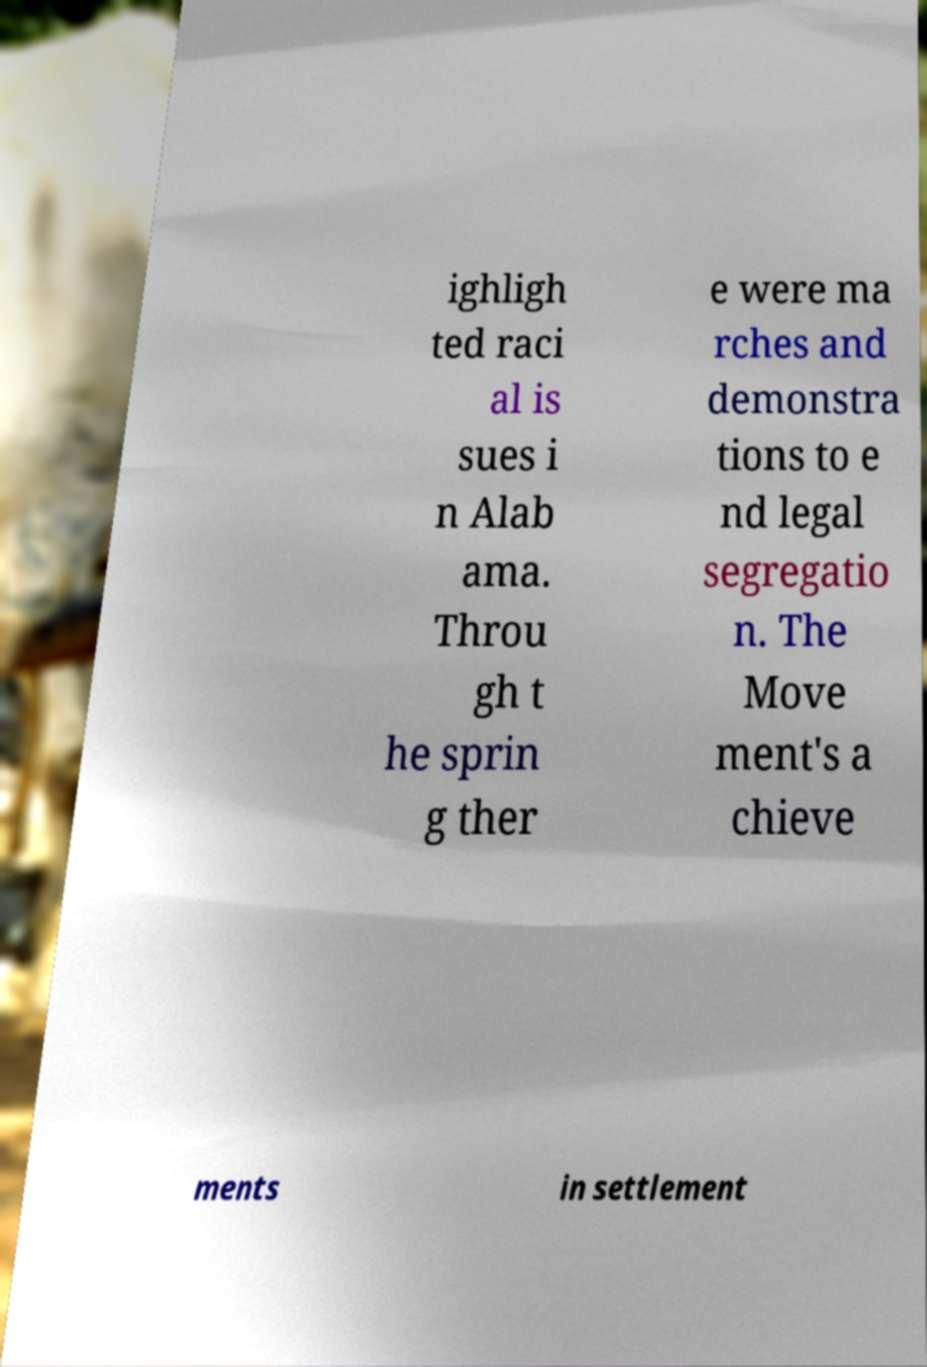Please read and relay the text visible in this image. What does it say? ighligh ted raci al is sues i n Alab ama. Throu gh t he sprin g ther e were ma rches and demonstra tions to e nd legal segregatio n. The Move ment's a chieve ments in settlement 